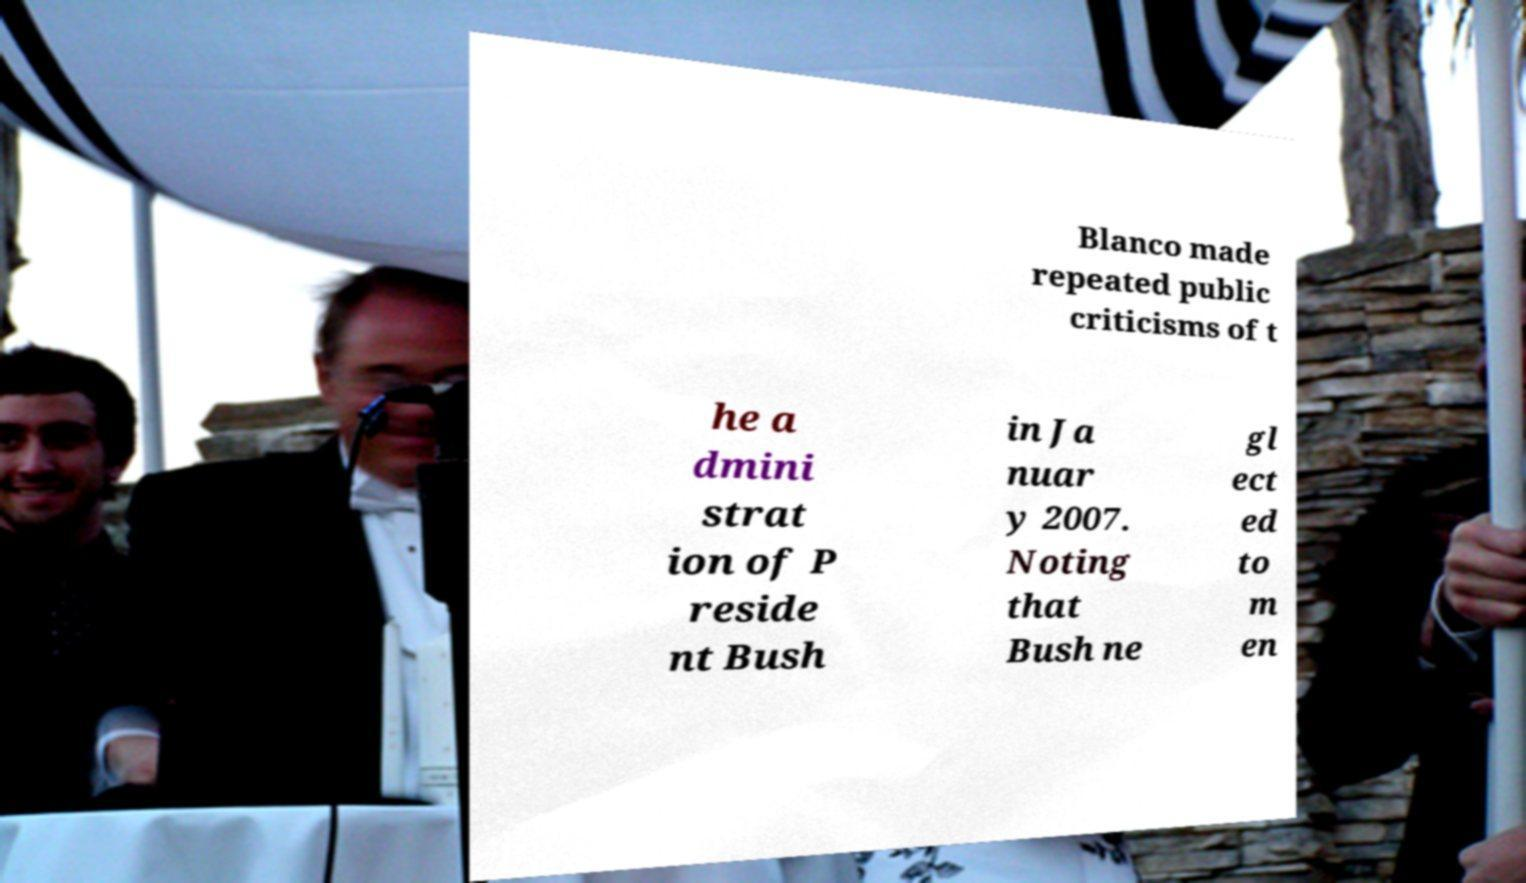I need the written content from this picture converted into text. Can you do that? Blanco made repeated public criticisms of t he a dmini strat ion of P reside nt Bush in Ja nuar y 2007. Noting that Bush ne gl ect ed to m en 